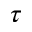<formula> <loc_0><loc_0><loc_500><loc_500>\tau</formula> 